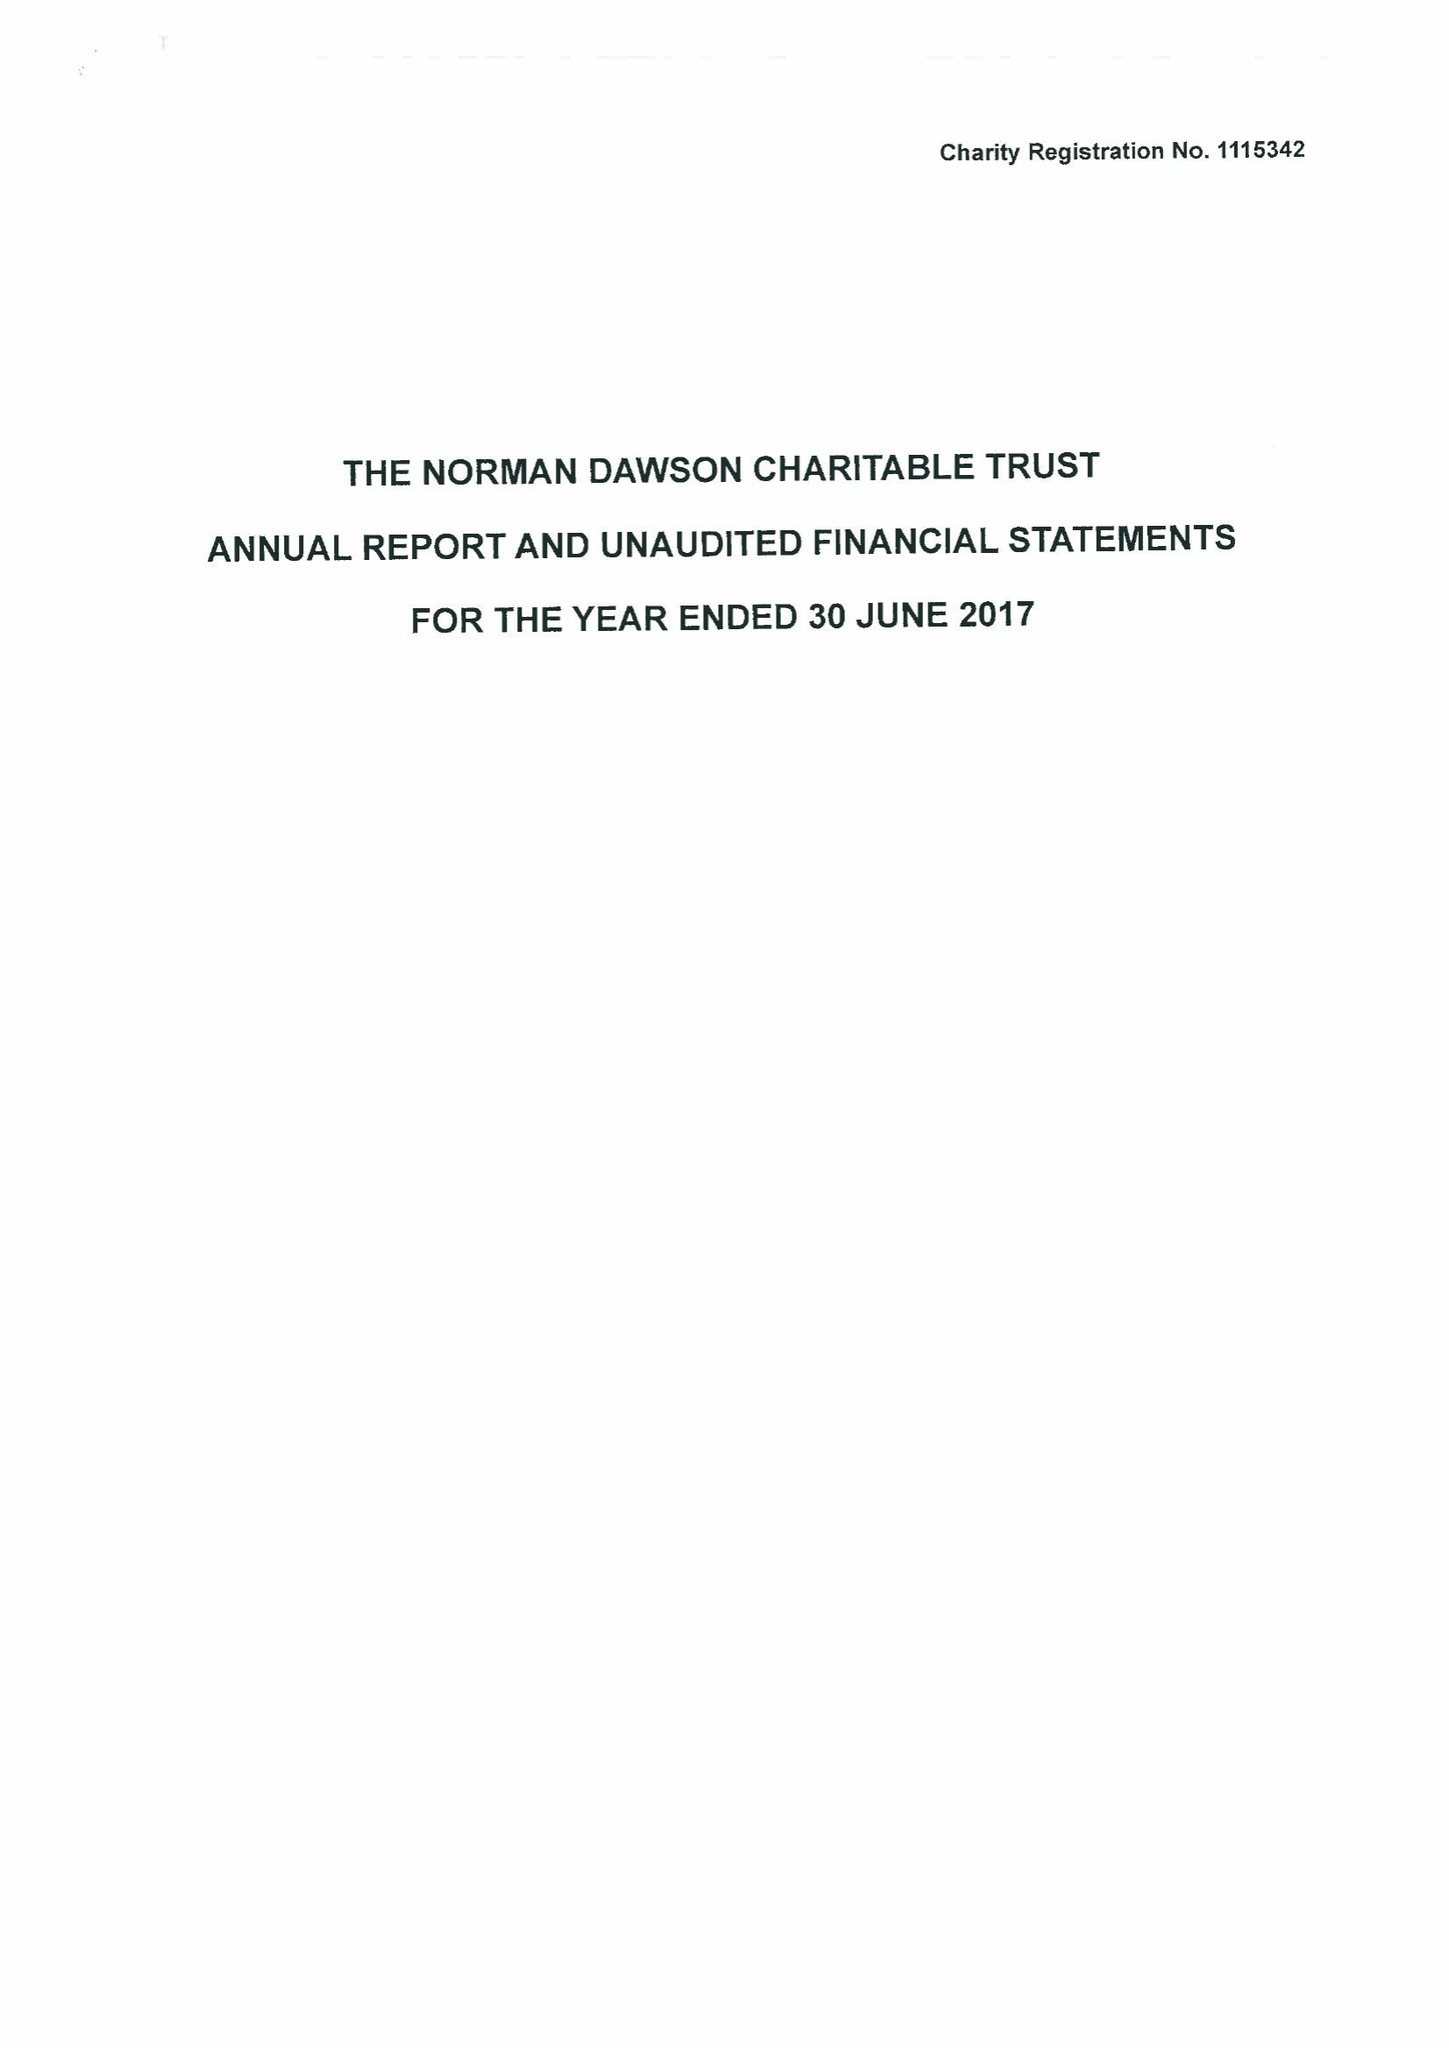What is the value for the spending_annually_in_british_pounds?
Answer the question using a single word or phrase. 62035.00 